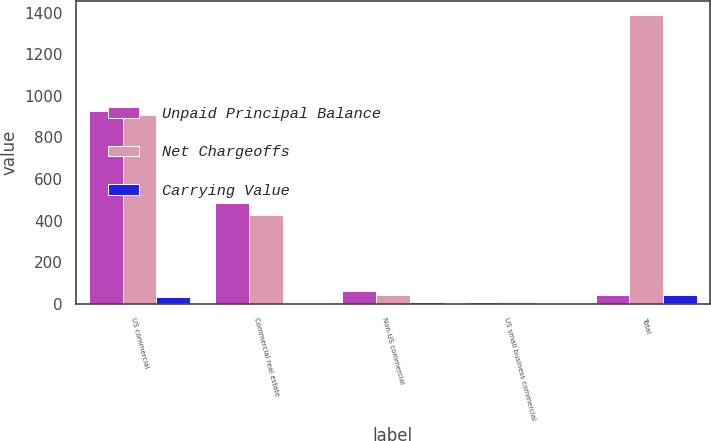<chart> <loc_0><loc_0><loc_500><loc_500><stacked_bar_chart><ecel><fcel>US commercial<fcel>Commercial real estate<fcel>Non-US commercial<fcel>US small business commercial<fcel>Total<nl><fcel>Unpaid Principal Balance<fcel>926<fcel>483<fcel>61<fcel>8<fcel>44<nl><fcel>Net Chargeoffs<fcel>910<fcel>425<fcel>44<fcel>9<fcel>1388<nl><fcel>Carrying Value<fcel>33<fcel>3<fcel>7<fcel>1<fcel>44<nl></chart> 